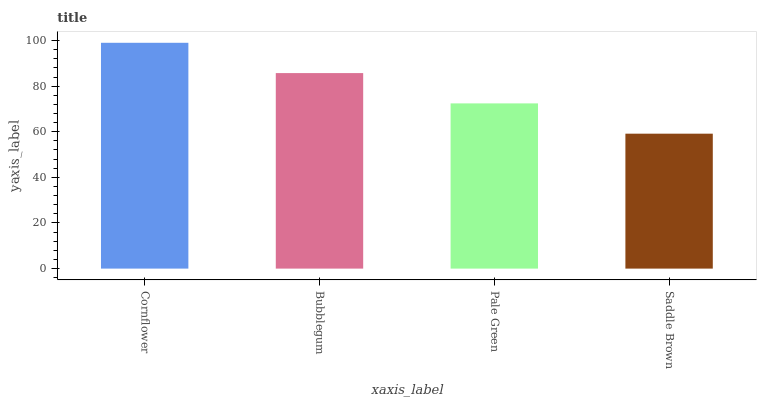Is Saddle Brown the minimum?
Answer yes or no. Yes. Is Cornflower the maximum?
Answer yes or no. Yes. Is Bubblegum the minimum?
Answer yes or no. No. Is Bubblegum the maximum?
Answer yes or no. No. Is Cornflower greater than Bubblegum?
Answer yes or no. Yes. Is Bubblegum less than Cornflower?
Answer yes or no. Yes. Is Bubblegum greater than Cornflower?
Answer yes or no. No. Is Cornflower less than Bubblegum?
Answer yes or no. No. Is Bubblegum the high median?
Answer yes or no. Yes. Is Pale Green the low median?
Answer yes or no. Yes. Is Pale Green the high median?
Answer yes or no. No. Is Cornflower the low median?
Answer yes or no. No. 